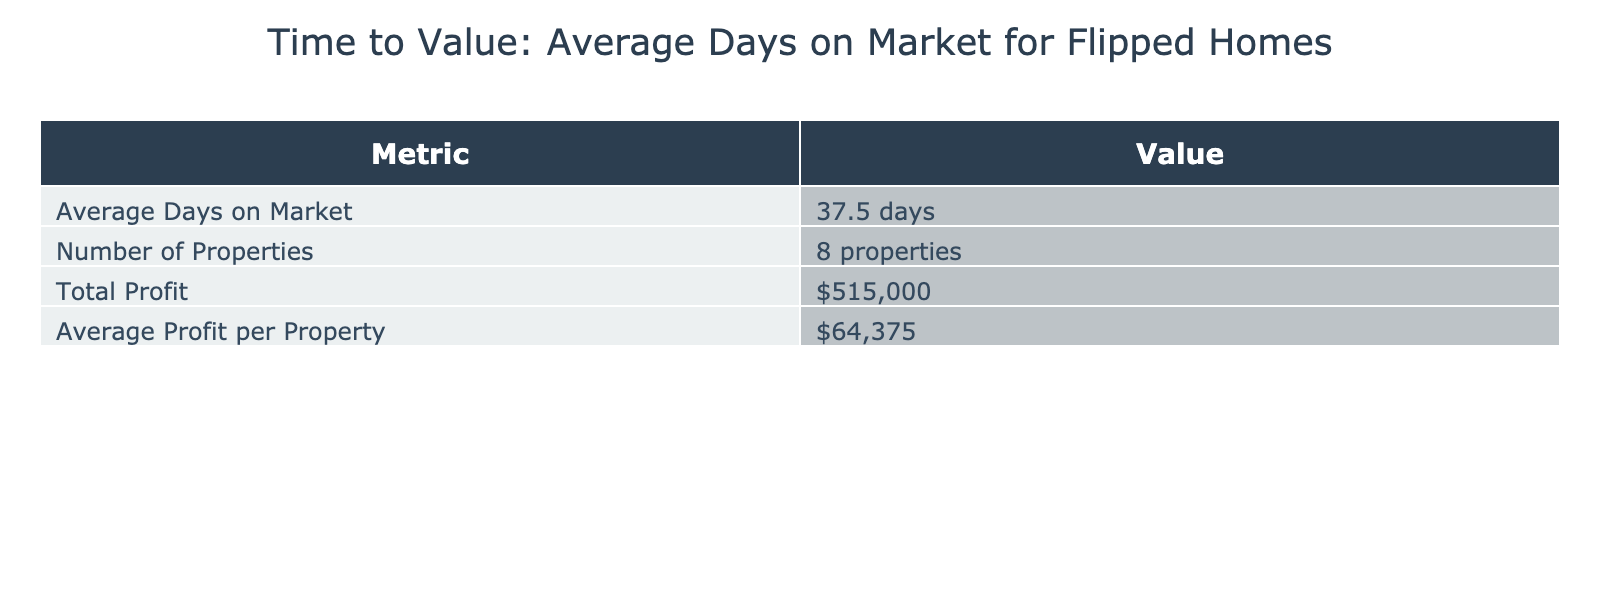What is the average number of days on market for the properties listed? The average days on market has been calculated by summing the days on market for all properties (30 + 45 + 25 + 60 + 15 + 50 + 35 + 40 = 350) and dividing by the total number of properties (8). Thus, the average is 350/8 = 43.75 days, which rounds to 43.8 days.
Answer: 43.8 days How many properties are included in the analysis? The total number of properties listed in the table is given in the "Number of Properties" metrics. There are 8 properties calculated in total.
Answer: 8 properties What is the total profit from all the properties sold? The total profit is calculated by summing the profit for each individual property. This equates to (40000 + 70000 + 60000 + 55000 + 80000 + 100000 + 48000 + 62000 = 490000).
Answer: $490,000 Is the average profit per property greater than $60,000? The average profit per property is computed by dividing the total profit ($490,000) by the number of properties (8). This calculates to $490,000/8 = $61,250, which is greater than $60,000.
Answer: Yes Which property had the shortest time on market? The property with the shortest time on market can be determined by identifying the minimum value in the "Days on Market" column, which is 15 days corresponding to the property at 654 Cedar Ct.
Answer: 654 Cedar Ct What is the profit from the property that had the longest days on market? The property with the longest days on market is identified first (321 Birch Blvd with 60 days). Its profit amount is then read from the table, which is $55,000.
Answer: $55,000 How much higher is the profit from 654 Cedar Ct compared to the average profit per property? The profit from 654 Cedar Ct is $80,000. The average profit per property is $61,250. To find the difference, we subtract the average profit from the profit of 654 Cedar Ct: $80,000 - $61,250 = $18,750.
Answer: $18,750 Which property has both a lower renovation cost and a shorter time on market than the average? First, the average renovation cost can be calculated (30000 + 50000 + 25000 + 20000 + 100000 + 150000 + 22000 + 18000 = 157000, then divide by 8 gives $19625). The average days on market is about 43.8 days. Comparing properties to find one with both a renovation cost less than $19,625 and days on market under 43.8 leads to the property at 789 Pine Rd, which meets both conditions (25 days on market and $25,000 renovation cost).
Answer: 789 Pine Rd 